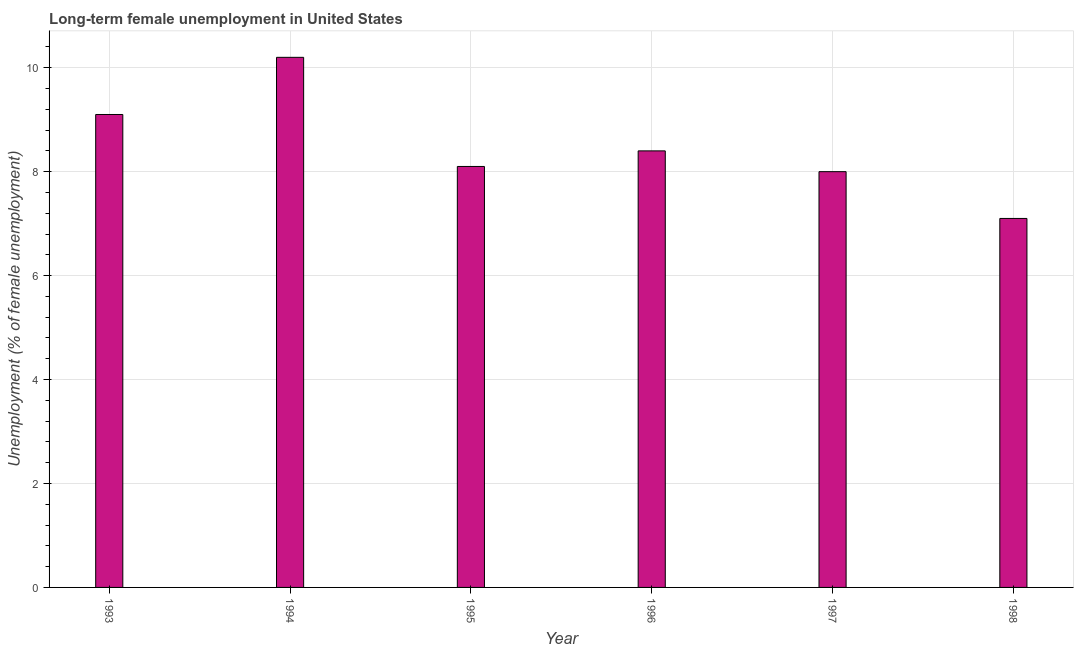Does the graph contain grids?
Provide a succinct answer. Yes. What is the title of the graph?
Provide a succinct answer. Long-term female unemployment in United States. What is the label or title of the Y-axis?
Make the answer very short. Unemployment (% of female unemployment). What is the long-term female unemployment in 1998?
Provide a succinct answer. 7.1. Across all years, what is the maximum long-term female unemployment?
Your response must be concise. 10.2. Across all years, what is the minimum long-term female unemployment?
Your answer should be very brief. 7.1. In which year was the long-term female unemployment maximum?
Your answer should be very brief. 1994. In which year was the long-term female unemployment minimum?
Provide a succinct answer. 1998. What is the sum of the long-term female unemployment?
Provide a short and direct response. 50.9. What is the average long-term female unemployment per year?
Give a very brief answer. 8.48. What is the median long-term female unemployment?
Give a very brief answer. 8.25. Do a majority of the years between 1993 and 1996 (inclusive) have long-term female unemployment greater than 6.8 %?
Ensure brevity in your answer.  Yes. What is the ratio of the long-term female unemployment in 1994 to that in 1995?
Offer a terse response. 1.26. What is the difference between the highest and the second highest long-term female unemployment?
Give a very brief answer. 1.1. How many bars are there?
Make the answer very short. 6. Are all the bars in the graph horizontal?
Offer a terse response. No. How many years are there in the graph?
Your answer should be very brief. 6. What is the Unemployment (% of female unemployment) in 1993?
Keep it short and to the point. 9.1. What is the Unemployment (% of female unemployment) of 1994?
Keep it short and to the point. 10.2. What is the Unemployment (% of female unemployment) in 1995?
Provide a succinct answer. 8.1. What is the Unemployment (% of female unemployment) in 1996?
Offer a terse response. 8.4. What is the Unemployment (% of female unemployment) of 1997?
Your answer should be very brief. 8. What is the Unemployment (% of female unemployment) in 1998?
Provide a succinct answer. 7.1. What is the difference between the Unemployment (% of female unemployment) in 1993 and 1997?
Your answer should be compact. 1.1. What is the difference between the Unemployment (% of female unemployment) in 1994 and 1997?
Make the answer very short. 2.2. What is the difference between the Unemployment (% of female unemployment) in 1994 and 1998?
Keep it short and to the point. 3.1. What is the difference between the Unemployment (% of female unemployment) in 1995 and 1997?
Make the answer very short. 0.1. What is the difference between the Unemployment (% of female unemployment) in 1996 and 1997?
Make the answer very short. 0.4. What is the ratio of the Unemployment (% of female unemployment) in 1993 to that in 1994?
Give a very brief answer. 0.89. What is the ratio of the Unemployment (% of female unemployment) in 1993 to that in 1995?
Provide a short and direct response. 1.12. What is the ratio of the Unemployment (% of female unemployment) in 1993 to that in 1996?
Provide a short and direct response. 1.08. What is the ratio of the Unemployment (% of female unemployment) in 1993 to that in 1997?
Your answer should be very brief. 1.14. What is the ratio of the Unemployment (% of female unemployment) in 1993 to that in 1998?
Your response must be concise. 1.28. What is the ratio of the Unemployment (% of female unemployment) in 1994 to that in 1995?
Keep it short and to the point. 1.26. What is the ratio of the Unemployment (% of female unemployment) in 1994 to that in 1996?
Provide a succinct answer. 1.21. What is the ratio of the Unemployment (% of female unemployment) in 1994 to that in 1997?
Make the answer very short. 1.27. What is the ratio of the Unemployment (% of female unemployment) in 1994 to that in 1998?
Your answer should be compact. 1.44. What is the ratio of the Unemployment (% of female unemployment) in 1995 to that in 1998?
Make the answer very short. 1.14. What is the ratio of the Unemployment (% of female unemployment) in 1996 to that in 1997?
Your answer should be very brief. 1.05. What is the ratio of the Unemployment (% of female unemployment) in 1996 to that in 1998?
Your response must be concise. 1.18. What is the ratio of the Unemployment (% of female unemployment) in 1997 to that in 1998?
Keep it short and to the point. 1.13. 